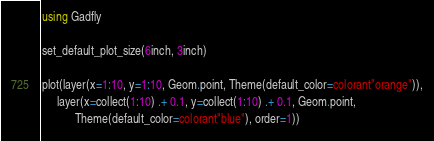<code> <loc_0><loc_0><loc_500><loc_500><_Julia_>using Gadfly

set_default_plot_size(6inch, 3inch)

plot(layer(x=1:10, y=1:10, Geom.point, Theme(default_color=colorant"orange")),
     layer(x=collect(1:10) .+ 0.1, y=collect(1:10) .+ 0.1, Geom.point,
           Theme(default_color=colorant"blue"), order=1))
</code> 